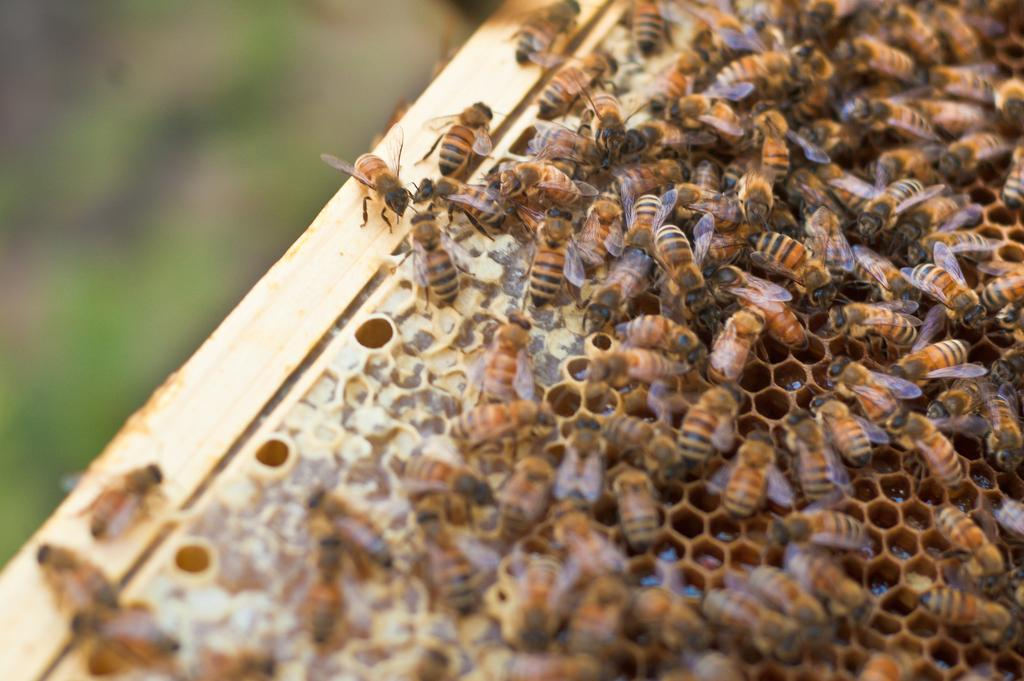What type of insects can be seen in the image? There are bees in the image. What structure is present in the image that is related to bees? There is a bee house in the image. What type of bomb is being used by the spy in the image? There is no bomb or spy present in the image; it features bees and a bee house. What type of minister is shown in the image? There is no minister present in the image; it features bees and a bee house. 